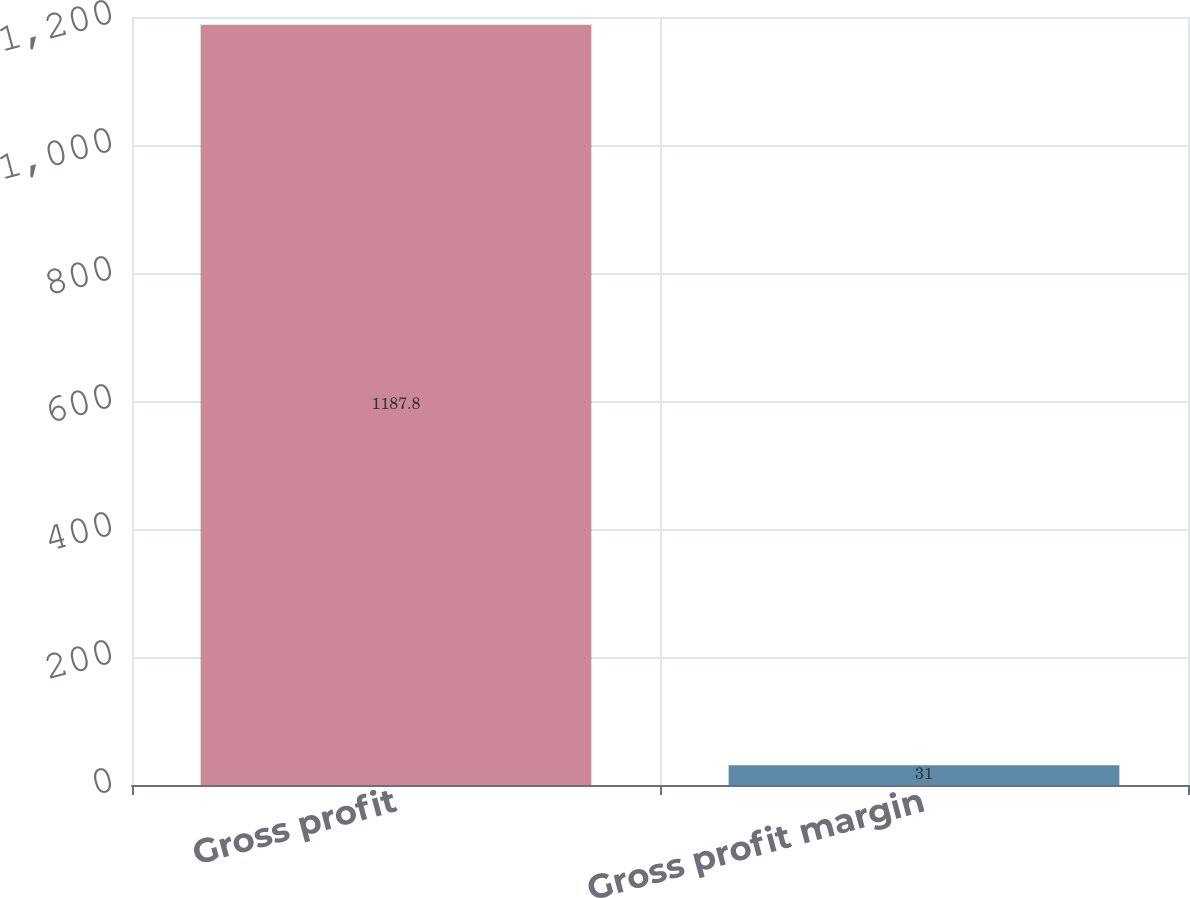<chart> <loc_0><loc_0><loc_500><loc_500><bar_chart><fcel>Gross profit<fcel>Gross profit margin<nl><fcel>1187.8<fcel>31<nl></chart> 